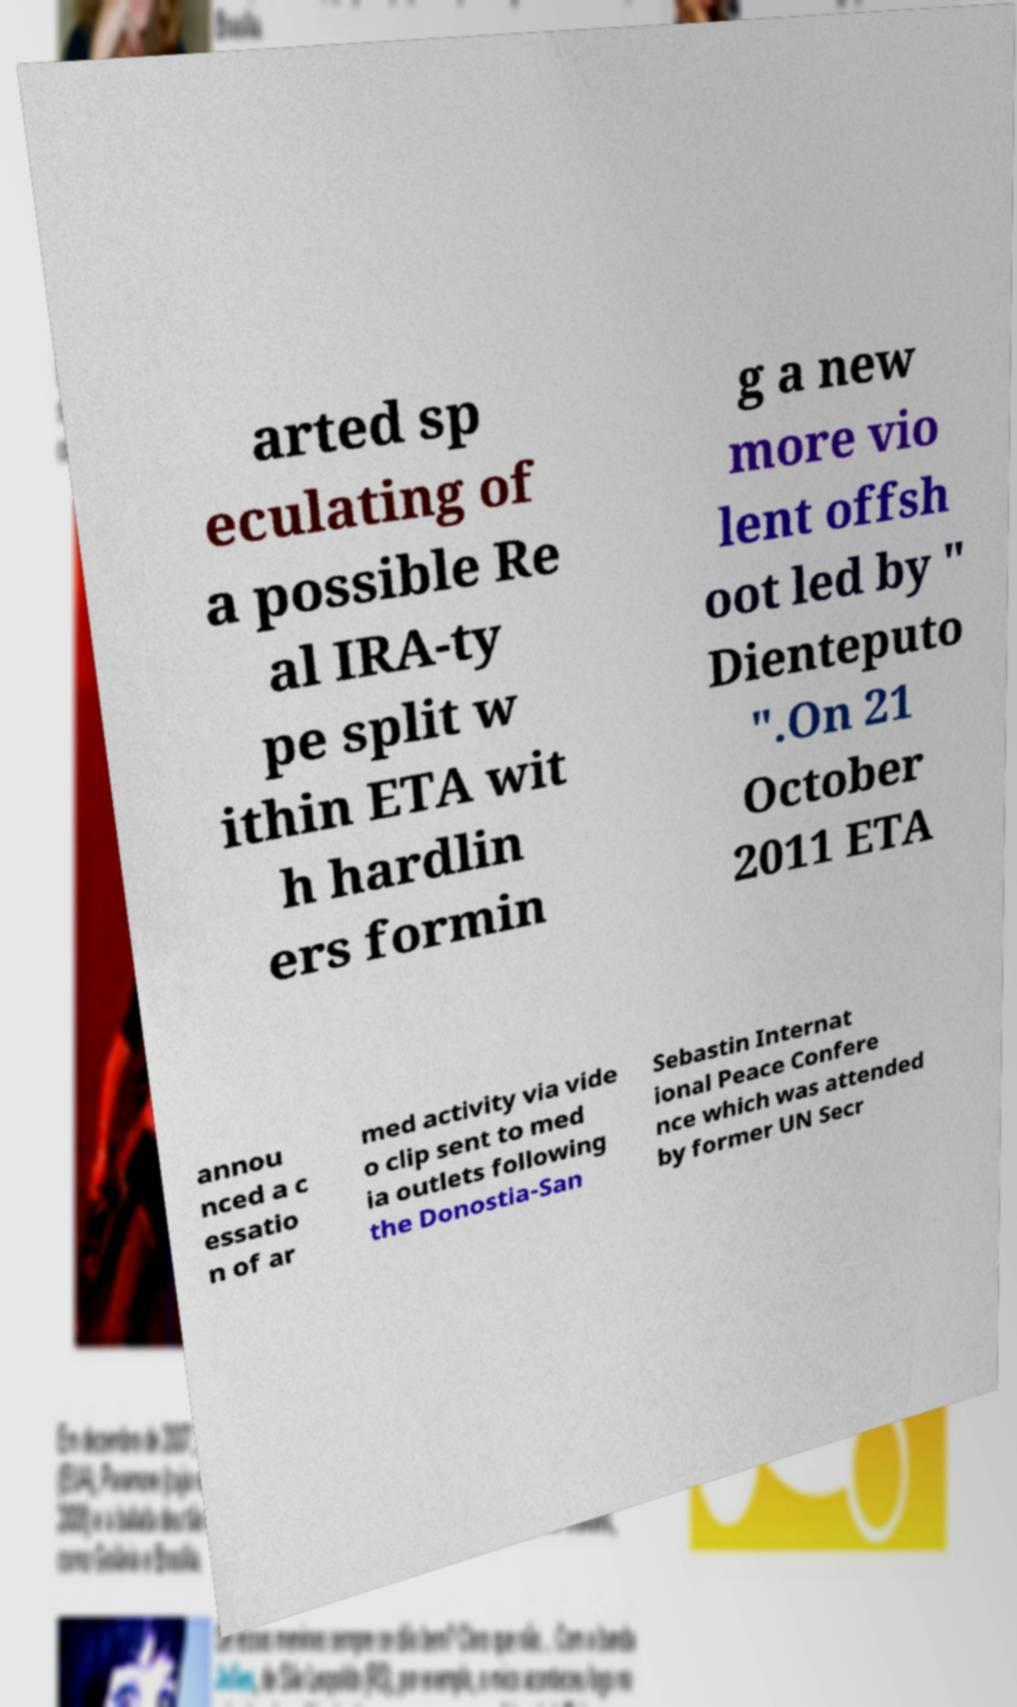I need the written content from this picture converted into text. Can you do that? arted sp eculating of a possible Re al IRA-ty pe split w ithin ETA wit h hardlin ers formin g a new more vio lent offsh oot led by " Dienteputo ".On 21 October 2011 ETA annou nced a c essatio n of ar med activity via vide o clip sent to med ia outlets following the Donostia-San Sebastin Internat ional Peace Confere nce which was attended by former UN Secr 